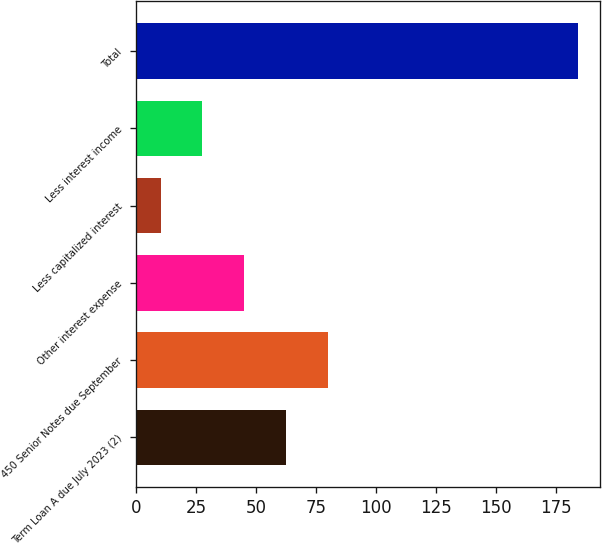Convert chart to OTSL. <chart><loc_0><loc_0><loc_500><loc_500><bar_chart><fcel>Term Loan A due July 2023 (2)<fcel>450 Senior Notes due September<fcel>Other interest expense<fcel>Less capitalized interest<fcel>Less interest income<fcel>Total<nl><fcel>62.47<fcel>79.86<fcel>45.08<fcel>10.3<fcel>27.69<fcel>184.2<nl></chart> 